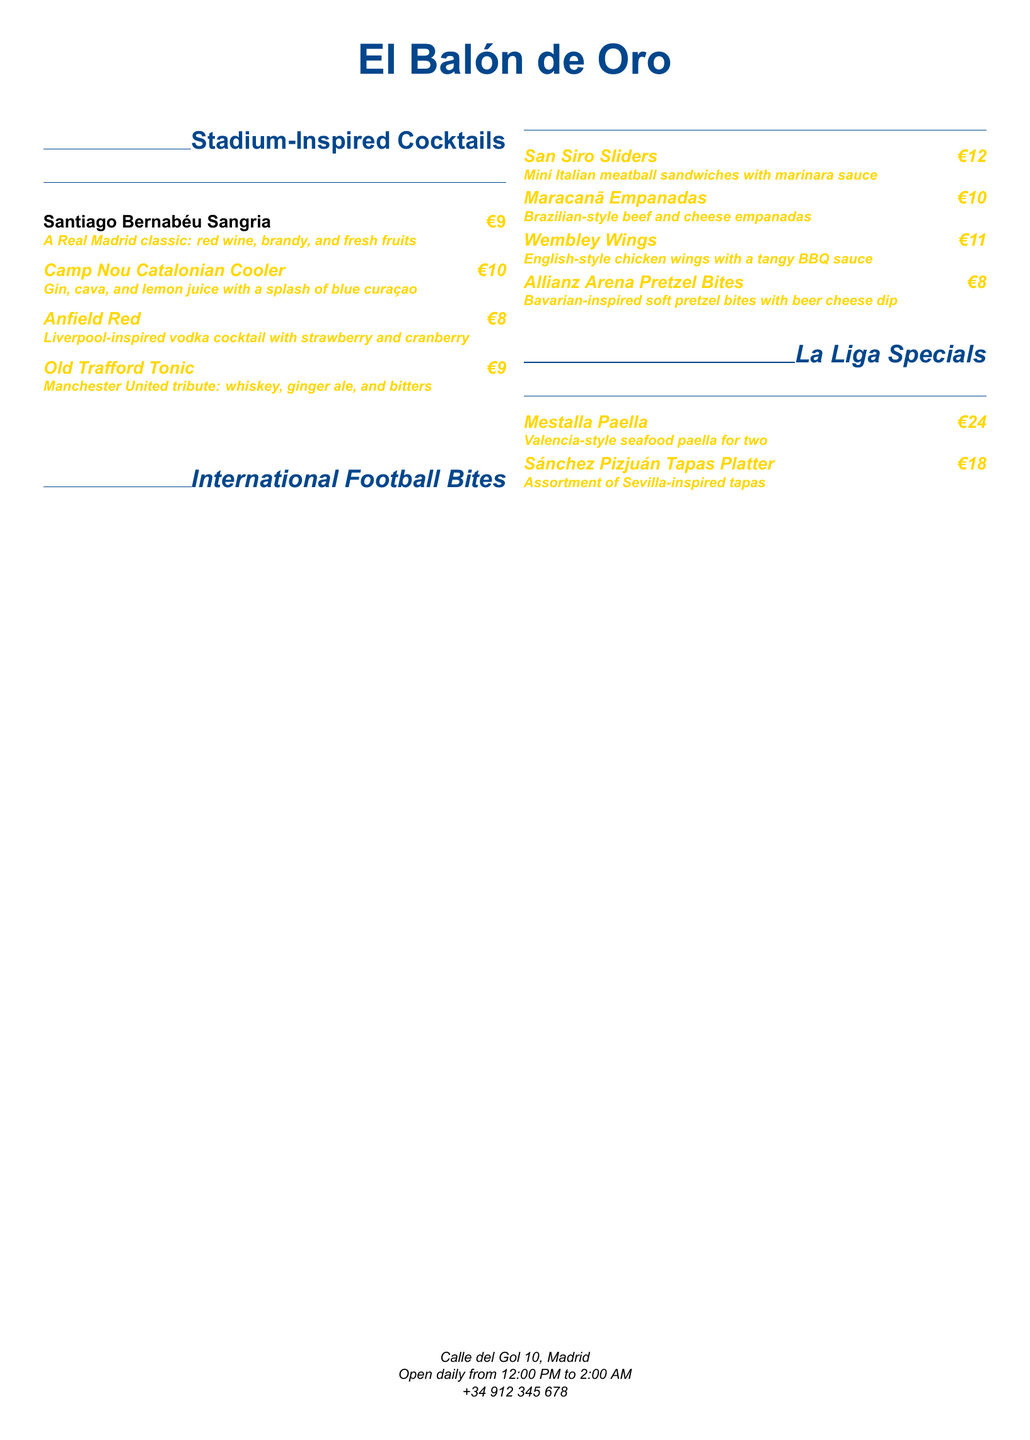What is the name of the bar? The name of the bar is specified at the top of the menu in a prominent title.
Answer: El Balón de Oro What cocktail costs €10? The menu lists several cocktails with their respective prices, highlighting those that cost €10.
Answer: Camp Nou Catalonian Cooler What is included in the Santiago Bernabéu Sangria? The description of the cocktail provides details about its ingredients.
Answer: Red wine, brandy, and fresh fruits How much are the San Siro Sliders? The price is indicated next to the item in the menu.
Answer: €12 Which snack is inspired by Brazilian cuisine? The menu specifies which bites are themed from various countries and their influences.
Answer: Maracanã Empanadas What type of wings are offered on the menu? The menu describes the style of the wings in the context of their national inspiration.
Answer: English-style chicken wings What does the Mestalla Paella serve? The menu indicates the quantity and type of dish provided under La Liga Specials.
Answer: For two What is the address of the bar? The document includes location details including the street name and city.
Answer: Calle del Gol 10, Madrid What time does the bar open? The operational hours are outlined at the bottom of the document.
Answer: 12:00 PM 